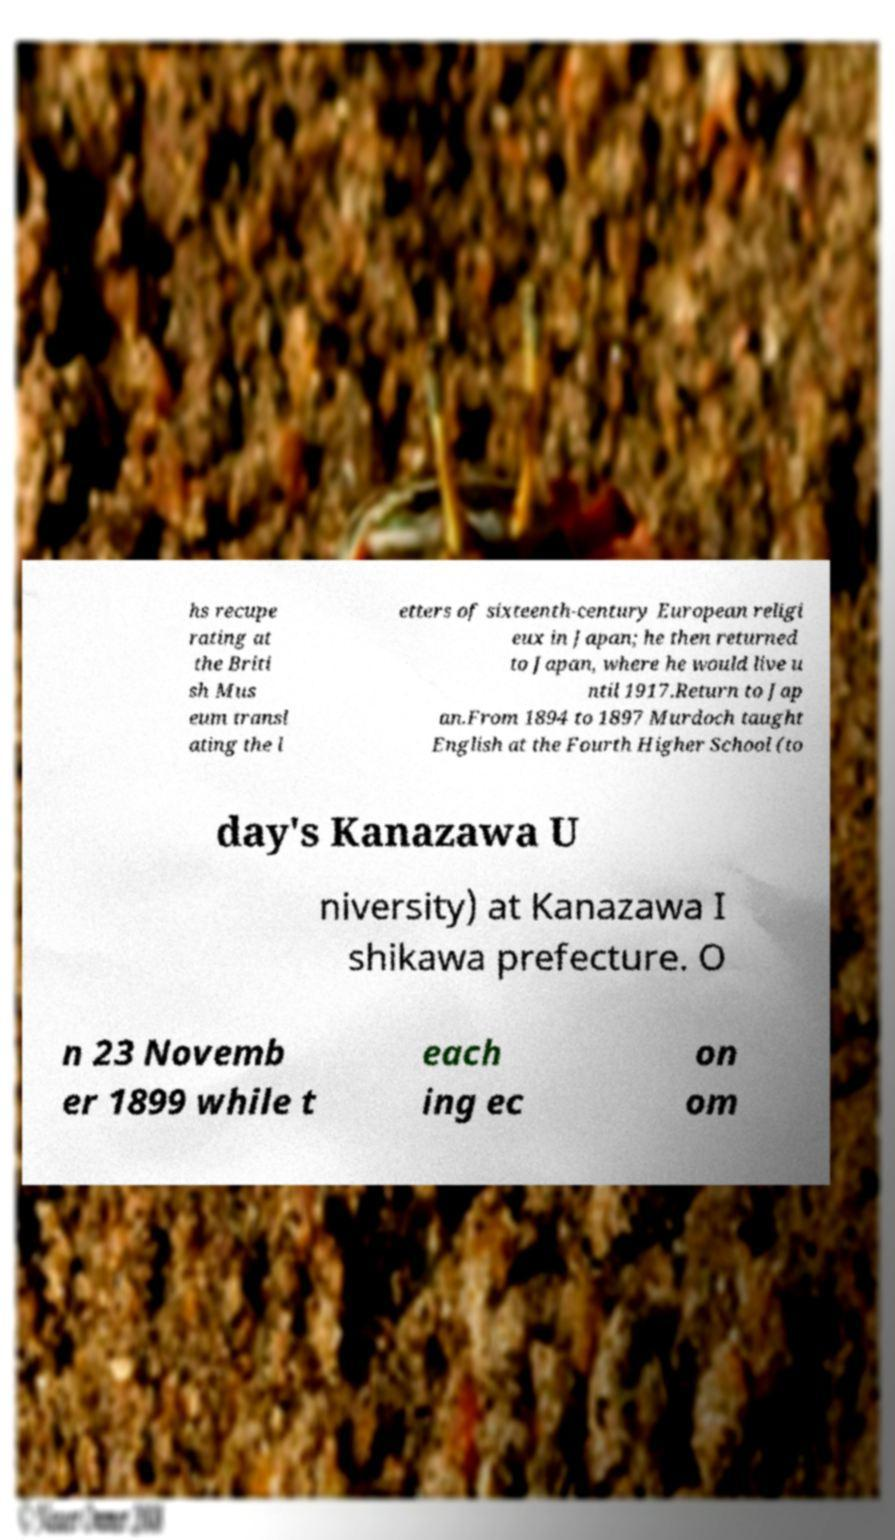Please identify and transcribe the text found in this image. hs recupe rating at the Briti sh Mus eum transl ating the l etters of sixteenth-century European religi eux in Japan; he then returned to Japan, where he would live u ntil 1917.Return to Jap an.From 1894 to 1897 Murdoch taught English at the Fourth Higher School (to day's Kanazawa U niversity) at Kanazawa I shikawa prefecture. O n 23 Novemb er 1899 while t each ing ec on om 